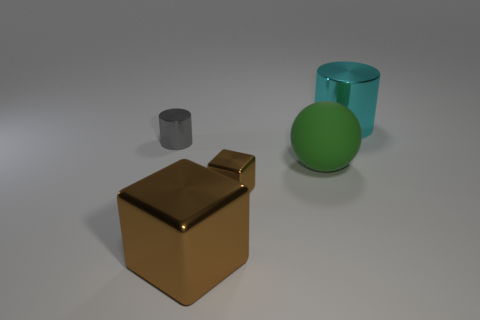How many gray cylinders are there? 1 